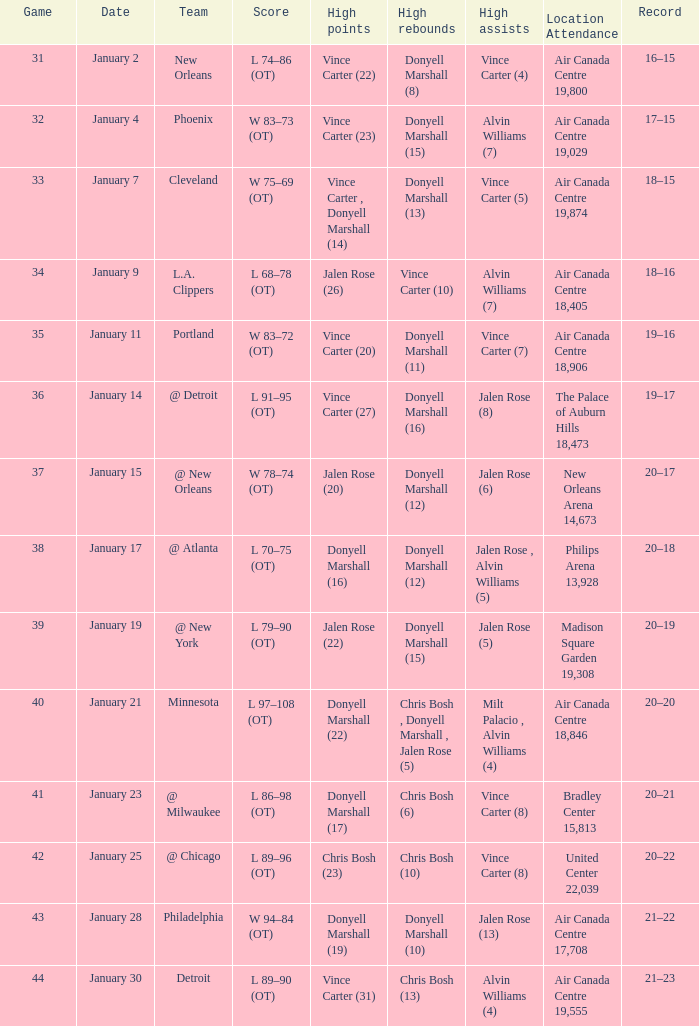Where was the match, and how many attended the match on january 2? Air Canada Centre 19,800. 